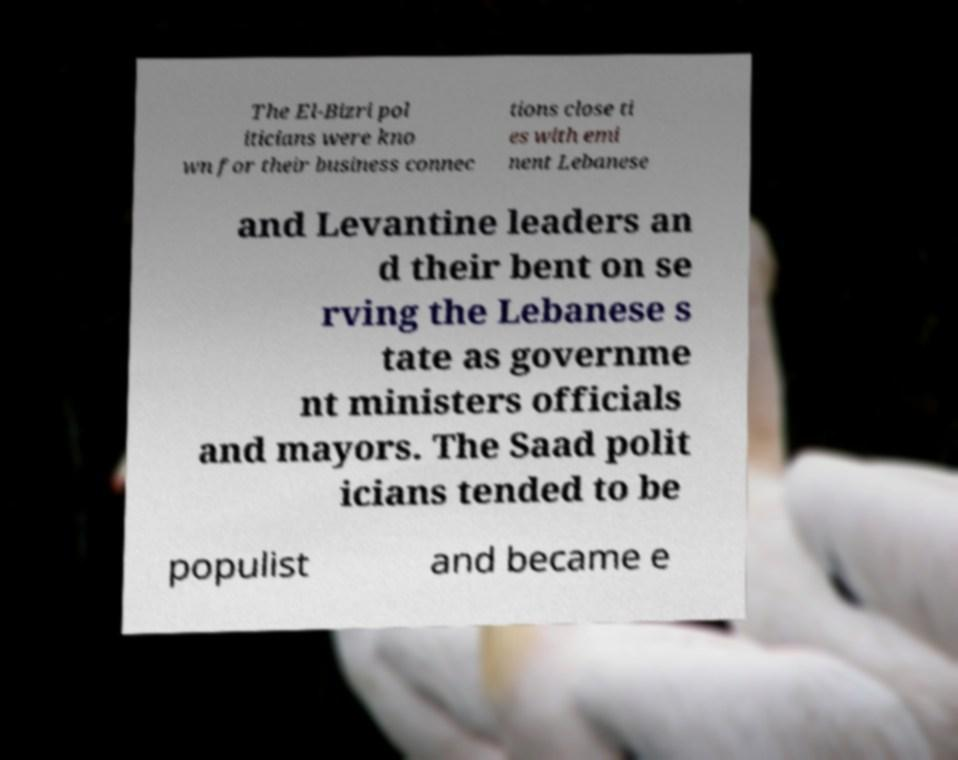Can you accurately transcribe the text from the provided image for me? The El-Bizri pol iticians were kno wn for their business connec tions close ti es with emi nent Lebanese and Levantine leaders an d their bent on se rving the Lebanese s tate as governme nt ministers officials and mayors. The Saad polit icians tended to be populist and became e 